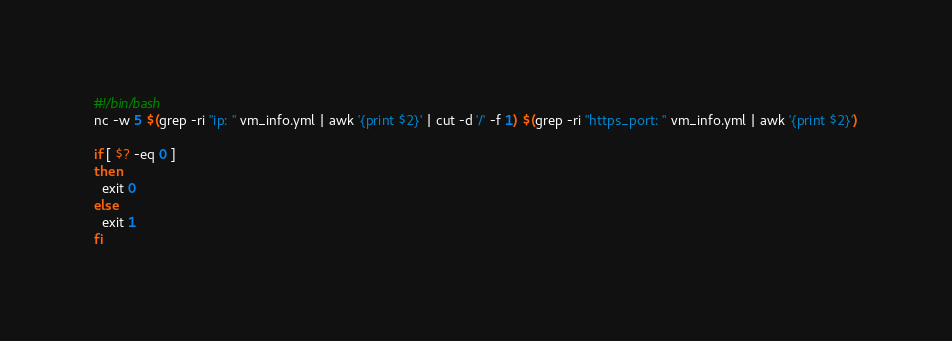Convert code to text. <code><loc_0><loc_0><loc_500><loc_500><_Bash_>#!/bin/bash
nc -w 5 $(grep -ri "ip: " vm_info.yml | awk '{print $2}' | cut -d '/' -f 1) $(grep -ri "https_port: " vm_info.yml | awk '{print $2}')

if [ $? -eq 0 ]
then
  exit 0
else
  exit 1
fi
</code> 